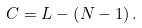Convert formula to latex. <formula><loc_0><loc_0><loc_500><loc_500>C = L - \left ( N - 1 \right ) .</formula> 